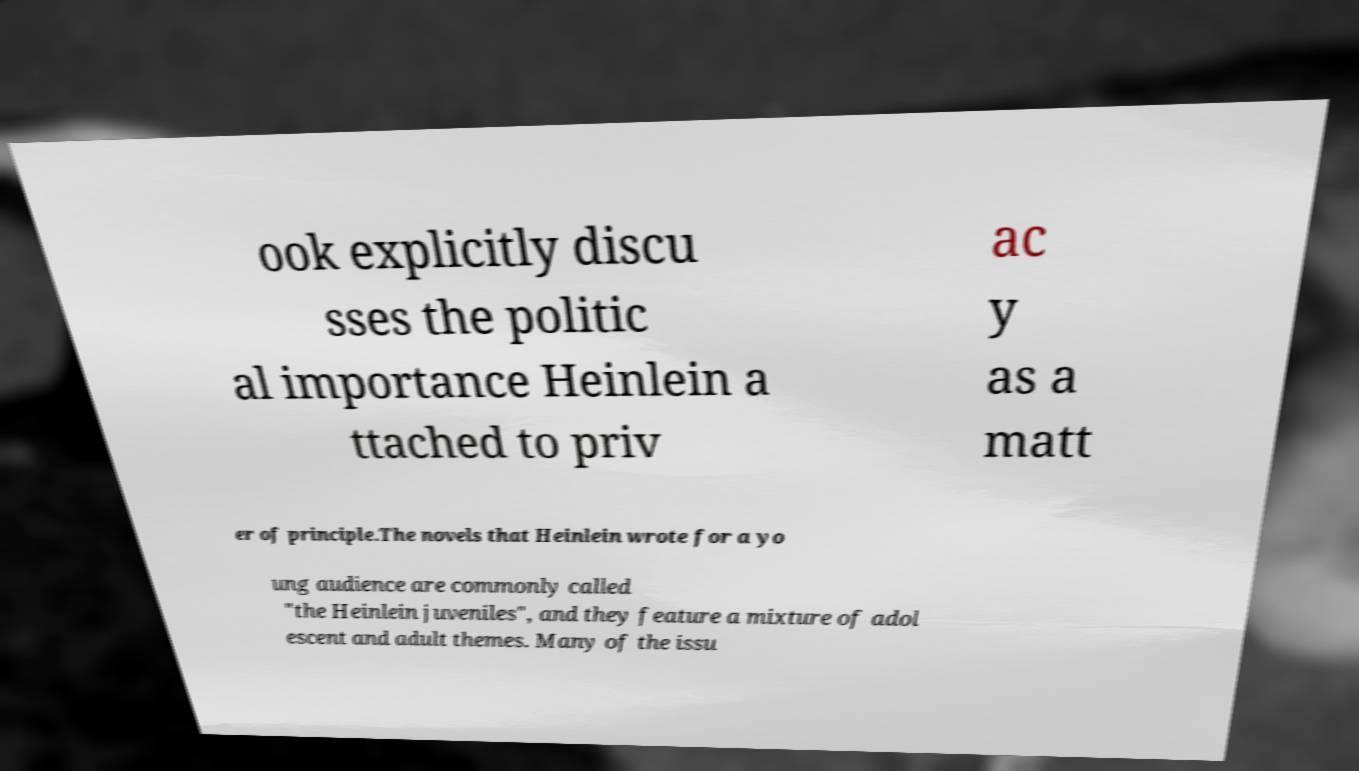Could you extract and type out the text from this image? ook explicitly discu sses the politic al importance Heinlein a ttached to priv ac y as a matt er of principle.The novels that Heinlein wrote for a yo ung audience are commonly called "the Heinlein juveniles", and they feature a mixture of adol escent and adult themes. Many of the issu 